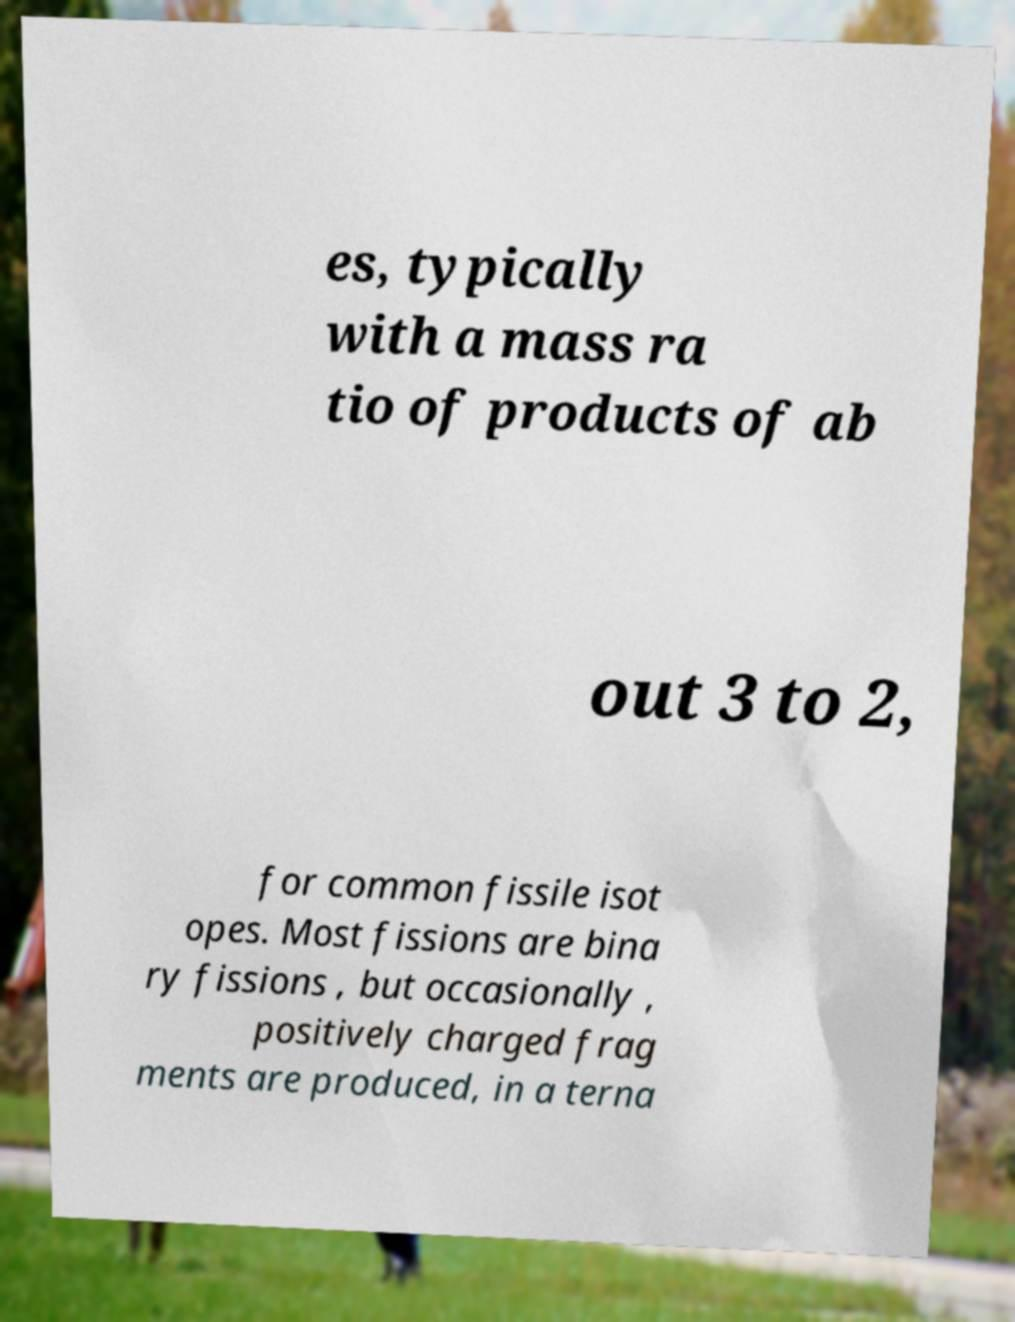There's text embedded in this image that I need extracted. Can you transcribe it verbatim? es, typically with a mass ra tio of products of ab out 3 to 2, for common fissile isot opes. Most fissions are bina ry fissions , but occasionally , positively charged frag ments are produced, in a terna 